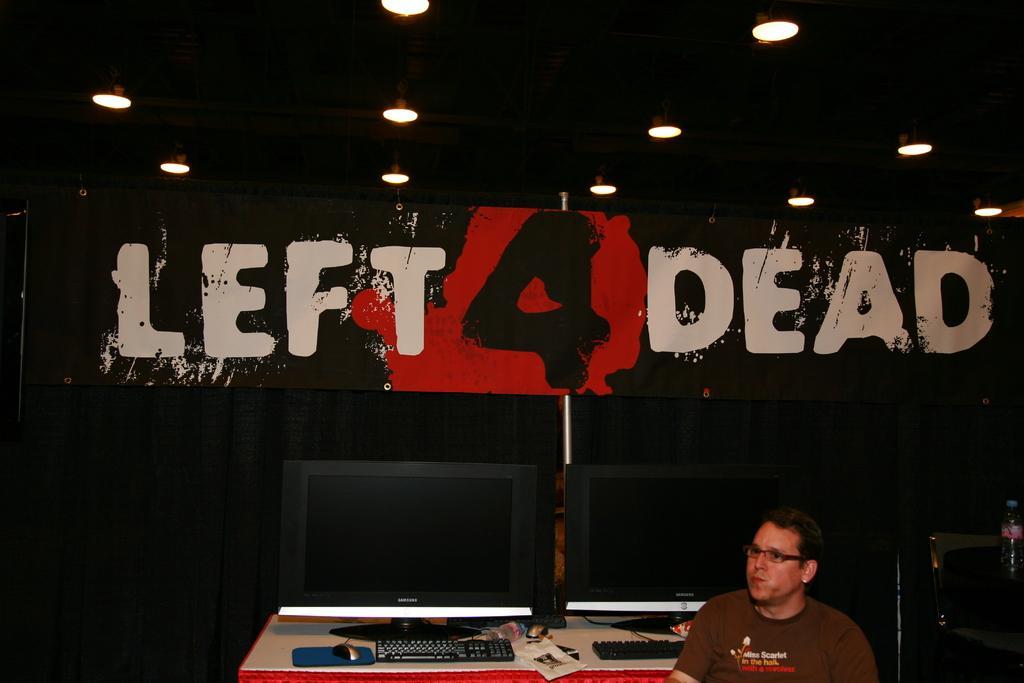How would you summarize this image in a sentence or two? In this picture we can see a man, he wore spectacles, behind to him we can find monitors, keyboards, mouses and other things on the table, beside to him we can see a bottle, in the background we can see a hoarding, metal rod and few lights. 